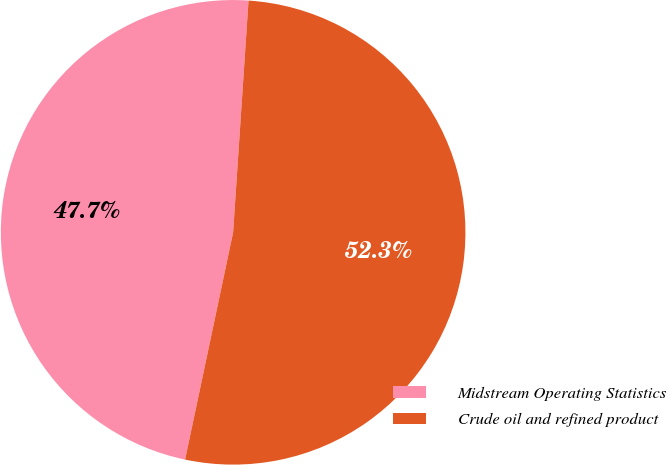<chart> <loc_0><loc_0><loc_500><loc_500><pie_chart><fcel>Midstream Operating Statistics<fcel>Crude oil and refined product<nl><fcel>47.74%<fcel>52.26%<nl></chart> 